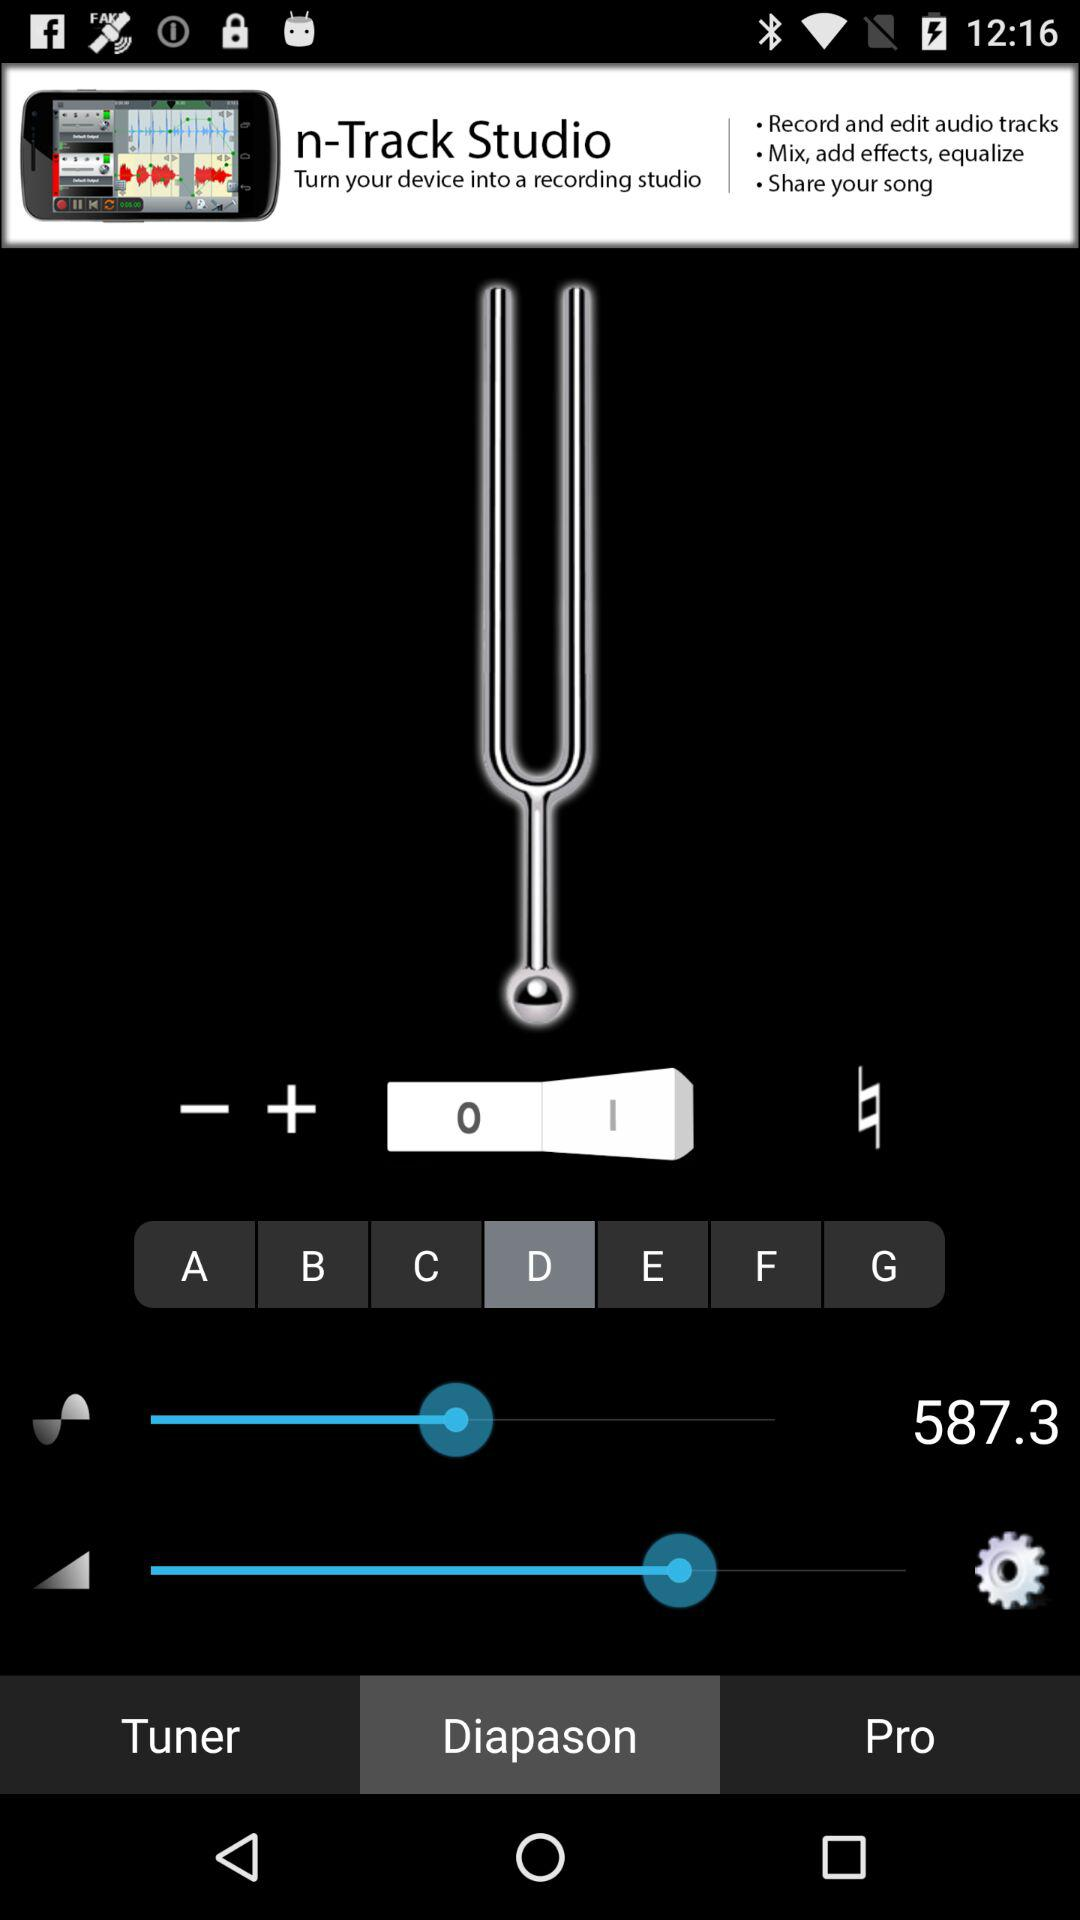What is the name of the application? The name of the application is "n-Track Studio". 